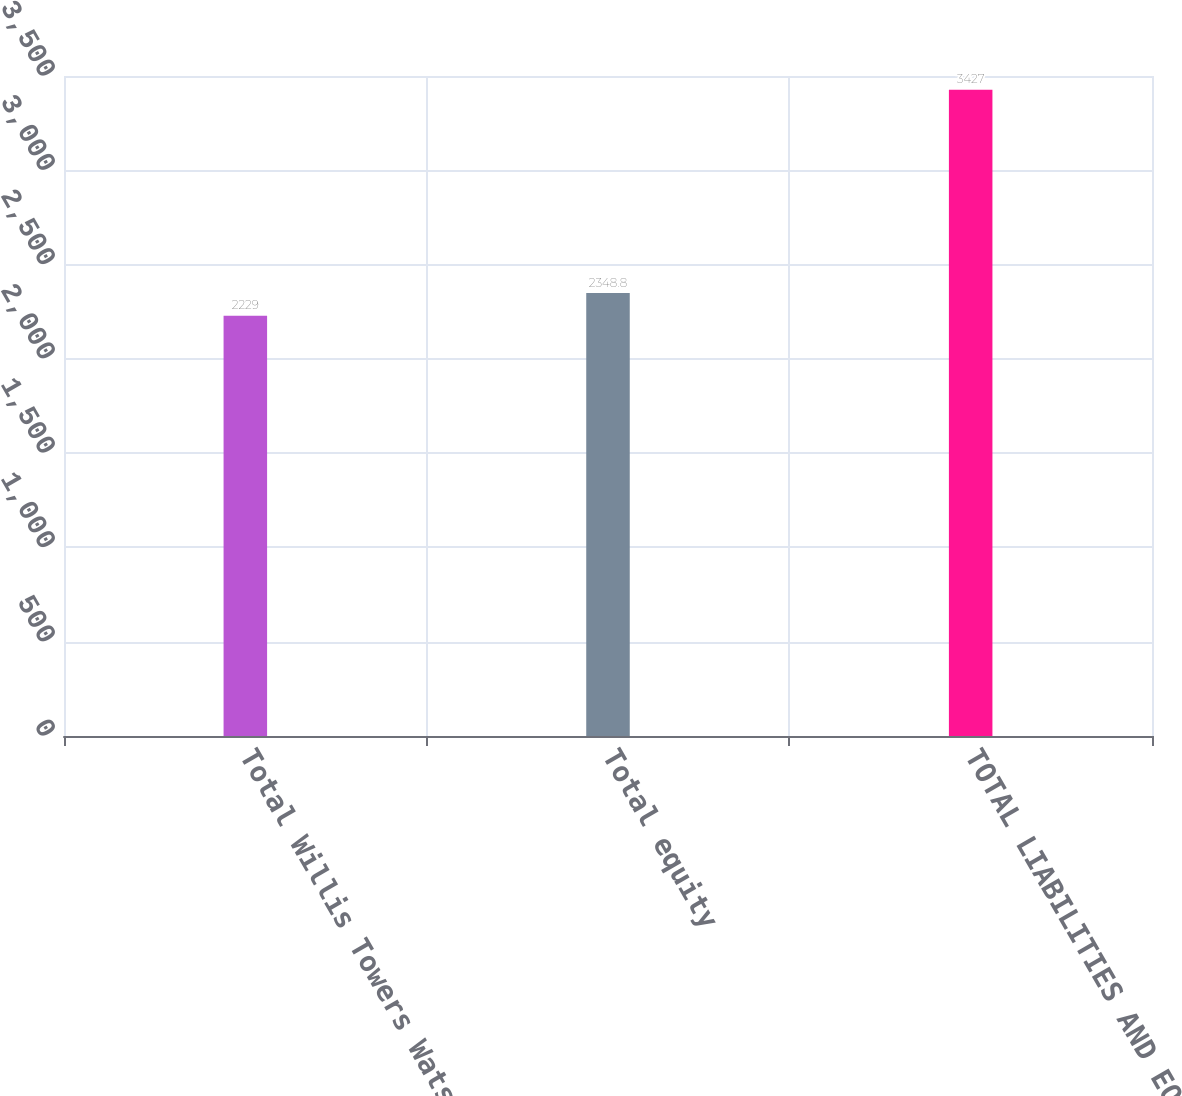Convert chart. <chart><loc_0><loc_0><loc_500><loc_500><bar_chart><fcel>Total Willis Towers Watson<fcel>Total equity<fcel>TOTAL LIABILITIES AND EQUITY<nl><fcel>2229<fcel>2348.8<fcel>3427<nl></chart> 